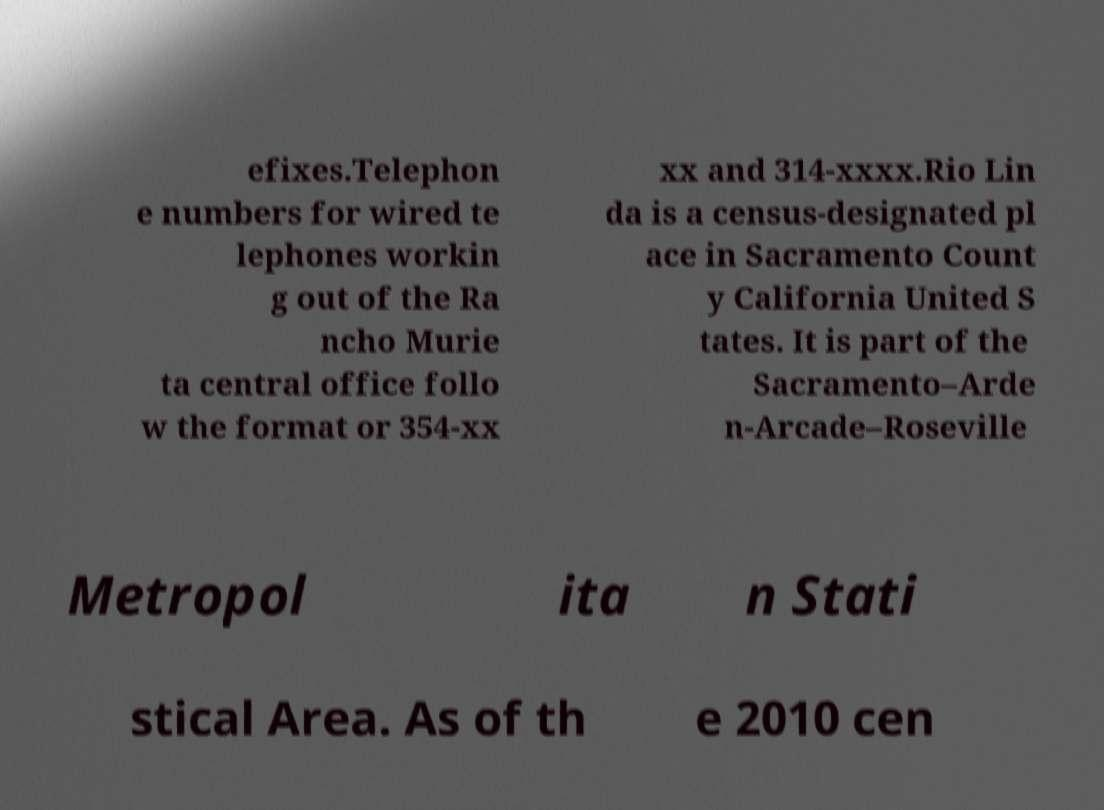Can you read and provide the text displayed in the image?This photo seems to have some interesting text. Can you extract and type it out for me? efixes.Telephon e numbers for wired te lephones workin g out of the Ra ncho Murie ta central office follo w the format or 354-xx xx and 314-xxxx.Rio Lin da is a census-designated pl ace in Sacramento Count y California United S tates. It is part of the Sacramento–Arde n-Arcade–Roseville Metropol ita n Stati stical Area. As of th e 2010 cen 